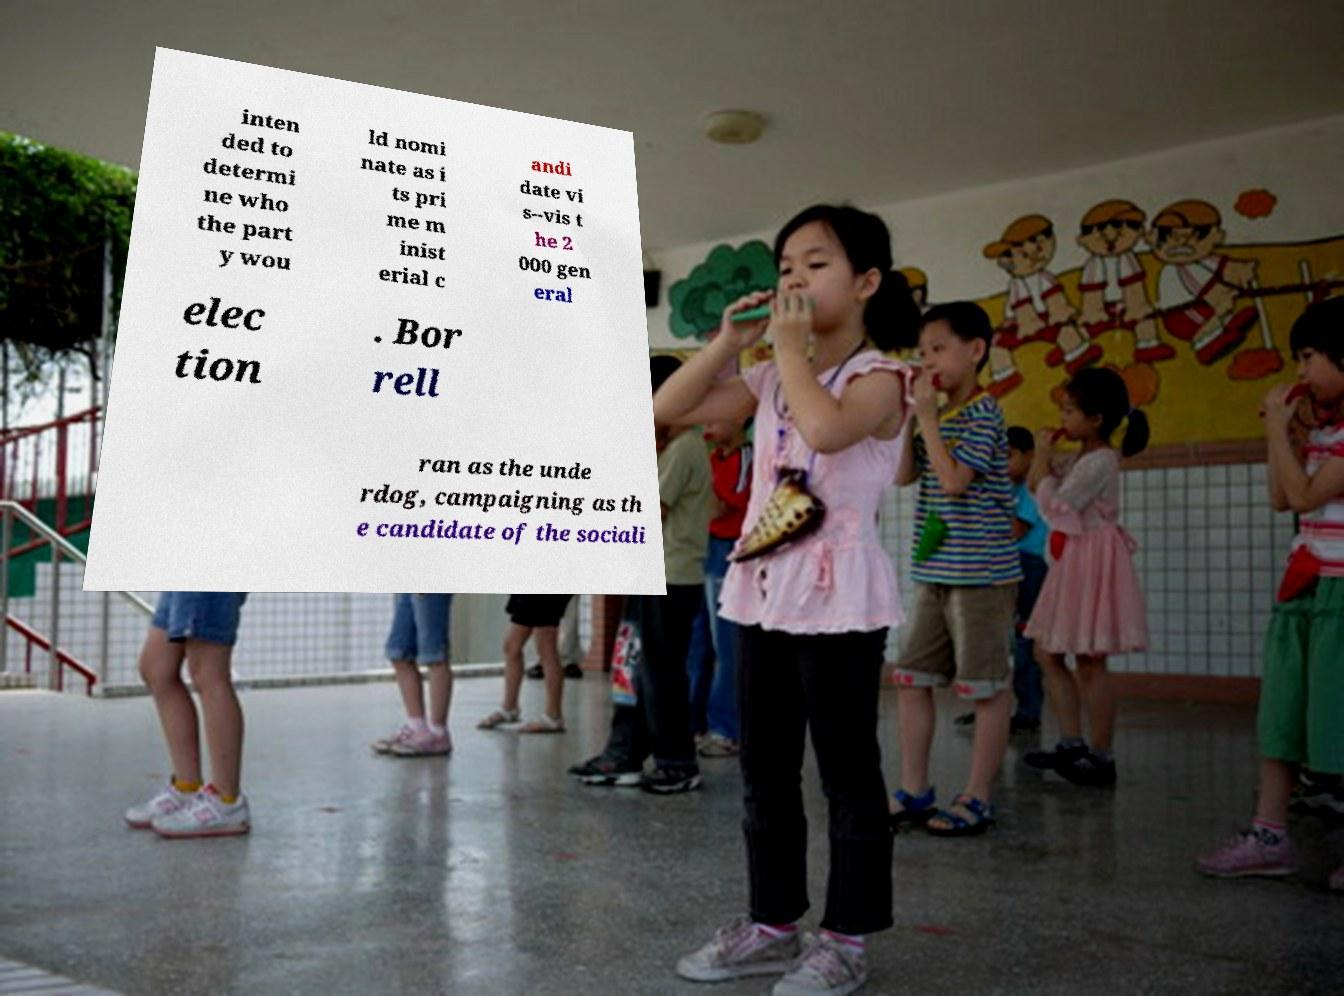For documentation purposes, I need the text within this image transcribed. Could you provide that? inten ded to determi ne who the part y wou ld nomi nate as i ts pri me m inist erial c andi date vi s--vis t he 2 000 gen eral elec tion . Bor rell ran as the unde rdog, campaigning as th e candidate of the sociali 